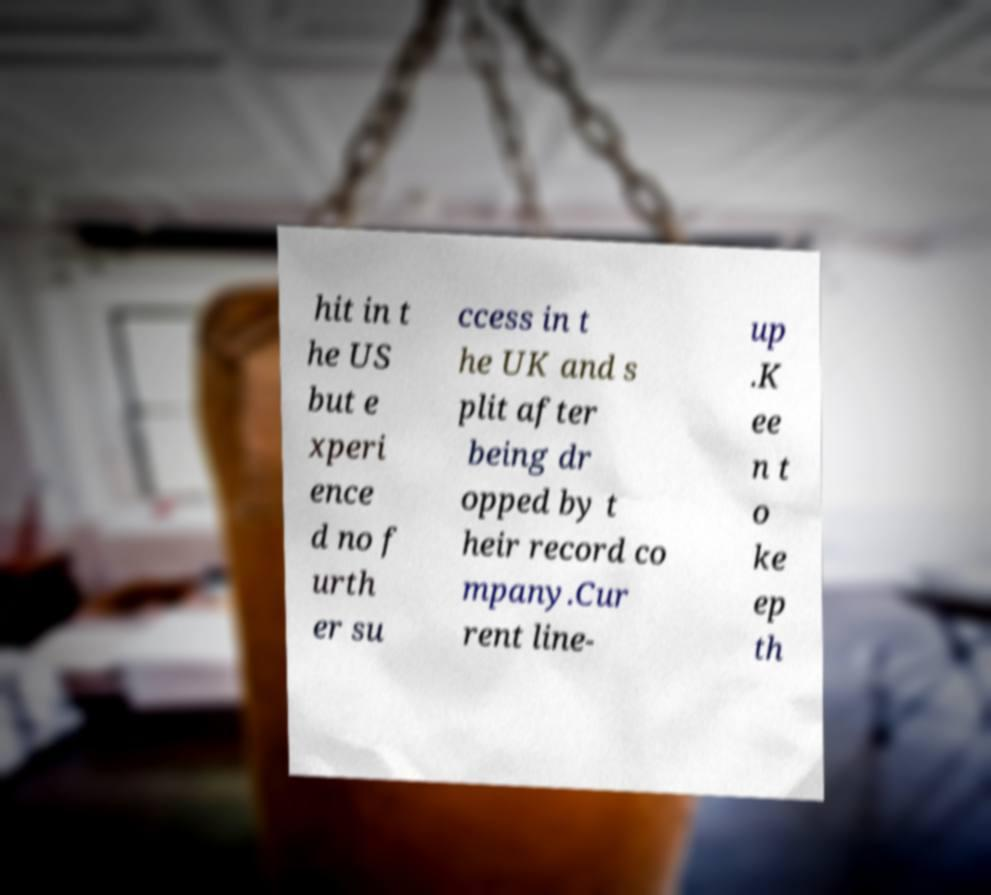Could you assist in decoding the text presented in this image and type it out clearly? hit in t he US but e xperi ence d no f urth er su ccess in t he UK and s plit after being dr opped by t heir record co mpany.Cur rent line- up .K ee n t o ke ep th 